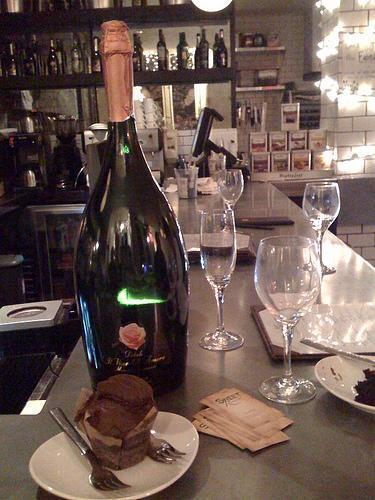How many wine glasses are there?
Give a very brief answer. 2. How many bottles are visible?
Give a very brief answer. 2. How many airplanes are there?
Give a very brief answer. 0. 